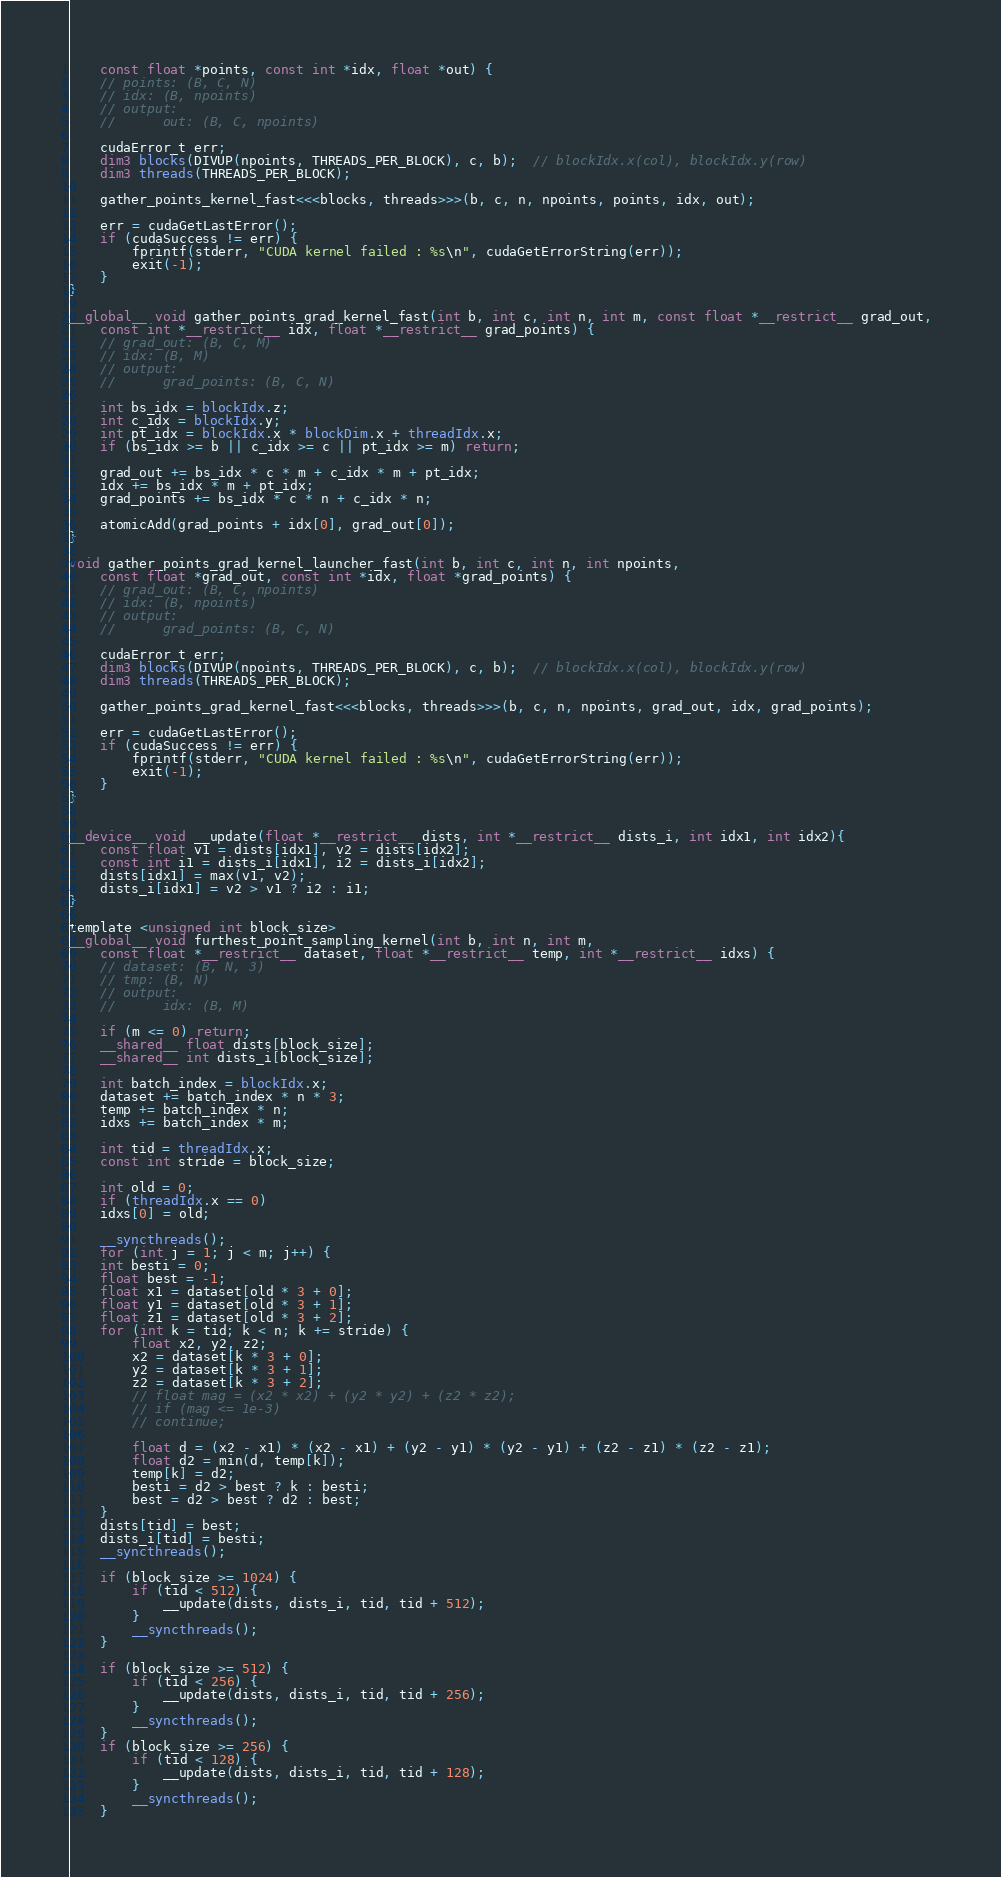Convert code to text. <code><loc_0><loc_0><loc_500><loc_500><_Cuda_>    const float *points, const int *idx, float *out) {
    // points: (B, C, N)
    // idx: (B, npoints)
    // output:
    //      out: (B, C, npoints)

    cudaError_t err;
    dim3 blocks(DIVUP(npoints, THREADS_PER_BLOCK), c, b);  // blockIdx.x(col), blockIdx.y(row)
    dim3 threads(THREADS_PER_BLOCK);

    gather_points_kernel_fast<<<blocks, threads>>>(b, c, n, npoints, points, idx, out);

    err = cudaGetLastError();
    if (cudaSuccess != err) {
        fprintf(stderr, "CUDA kernel failed : %s\n", cudaGetErrorString(err));
        exit(-1);
    }
}

__global__ void gather_points_grad_kernel_fast(int b, int c, int n, int m, const float *__restrict__ grad_out, 
    const int *__restrict__ idx, float *__restrict__ grad_points) {
    // grad_out: (B, C, M)
    // idx: (B, M)
    // output:
    //      grad_points: (B, C, N)

    int bs_idx = blockIdx.z;
    int c_idx = blockIdx.y;
    int pt_idx = blockIdx.x * blockDim.x + threadIdx.x;
    if (bs_idx >= b || c_idx >= c || pt_idx >= m) return;

    grad_out += bs_idx * c * m + c_idx * m + pt_idx;
    idx += bs_idx * m + pt_idx;
    grad_points += bs_idx * c * n + c_idx * n;

    atomicAdd(grad_points + idx[0], grad_out[0]);
}

void gather_points_grad_kernel_launcher_fast(int b, int c, int n, int npoints, 
    const float *grad_out, const int *idx, float *grad_points) {
    // grad_out: (B, C, npoints)
    // idx: (B, npoints)
    // output:
    //      grad_points: (B, C, N)

    cudaError_t err;
    dim3 blocks(DIVUP(npoints, THREADS_PER_BLOCK), c, b);  // blockIdx.x(col), blockIdx.y(row)
    dim3 threads(THREADS_PER_BLOCK);

    gather_points_grad_kernel_fast<<<blocks, threads>>>(b, c, n, npoints, grad_out, idx, grad_points);

    err = cudaGetLastError();
    if (cudaSuccess != err) {
        fprintf(stderr, "CUDA kernel failed : %s\n", cudaGetErrorString(err));
        exit(-1);
    }
}


__device__ void __update(float *__restrict__ dists, int *__restrict__ dists_i, int idx1, int idx2){
    const float v1 = dists[idx1], v2 = dists[idx2];
    const int i1 = dists_i[idx1], i2 = dists_i[idx2];
    dists[idx1] = max(v1, v2);
    dists_i[idx1] = v2 > v1 ? i2 : i1;
}

template <unsigned int block_size>
__global__ void furthest_point_sampling_kernel(int b, int n, int m, 
    const float *__restrict__ dataset, float *__restrict__ temp, int *__restrict__ idxs) {
    // dataset: (B, N, 3)
    // tmp: (B, N)
    // output:
    //      idx: (B, M)

    if (m <= 0) return;
    __shared__ float dists[block_size];
    __shared__ int dists_i[block_size];

    int batch_index = blockIdx.x;
    dataset += batch_index * n * 3;
    temp += batch_index * n;
    idxs += batch_index * m;

    int tid = threadIdx.x;
    const int stride = block_size;

    int old = 0;
    if (threadIdx.x == 0)
    idxs[0] = old;

    __syncthreads();
    for (int j = 1; j < m; j++) {
    int besti = 0;
    float best = -1;
    float x1 = dataset[old * 3 + 0];
    float y1 = dataset[old * 3 + 1];
    float z1 = dataset[old * 3 + 2];
    for (int k = tid; k < n; k += stride) {
        float x2, y2, z2;
        x2 = dataset[k * 3 + 0];
        y2 = dataset[k * 3 + 1];
        z2 = dataset[k * 3 + 2];
        // float mag = (x2 * x2) + (y2 * y2) + (z2 * z2);
        // if (mag <= 1e-3)
        // continue;

        float d = (x2 - x1) * (x2 - x1) + (y2 - y1) * (y2 - y1) + (z2 - z1) * (z2 - z1);
        float d2 = min(d, temp[k]);
        temp[k] = d2;
        besti = d2 > best ? k : besti;
        best = d2 > best ? d2 : best;
    }
    dists[tid] = best;
    dists_i[tid] = besti;
    __syncthreads();

    if (block_size >= 1024) {
        if (tid < 512) {
            __update(dists, dists_i, tid, tid + 512);
        }
        __syncthreads();
    }

    if (block_size >= 512) {
        if (tid < 256) {
            __update(dists, dists_i, tid, tid + 256);
        }
        __syncthreads();
    }
    if (block_size >= 256) {
        if (tid < 128) {
            __update(dists, dists_i, tid, tid + 128);
        }
        __syncthreads();
    }</code> 